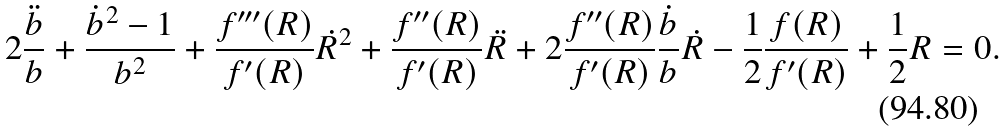Convert formula to latex. <formula><loc_0><loc_0><loc_500><loc_500>2 \frac { \ddot { b } } { b } + \frac { { \dot { b } } ^ { 2 } - 1 } { b ^ { 2 } } + \frac { f ^ { \prime \prime \prime } ( R ) } { f ^ { \prime } ( R ) } \dot { R } ^ { 2 } + \frac { f ^ { \prime \prime } ( R ) } { f ^ { \prime } ( R ) } \ddot { R } + 2 \frac { f ^ { \prime \prime } ( R ) } { f ^ { \prime } ( R ) } \frac { \dot { b } } { b } \dot { R } - \frac { 1 } { 2 } \frac { f ( R ) } { f ^ { \prime } ( R ) } + \frac { 1 } { 2 } R = 0 .</formula> 